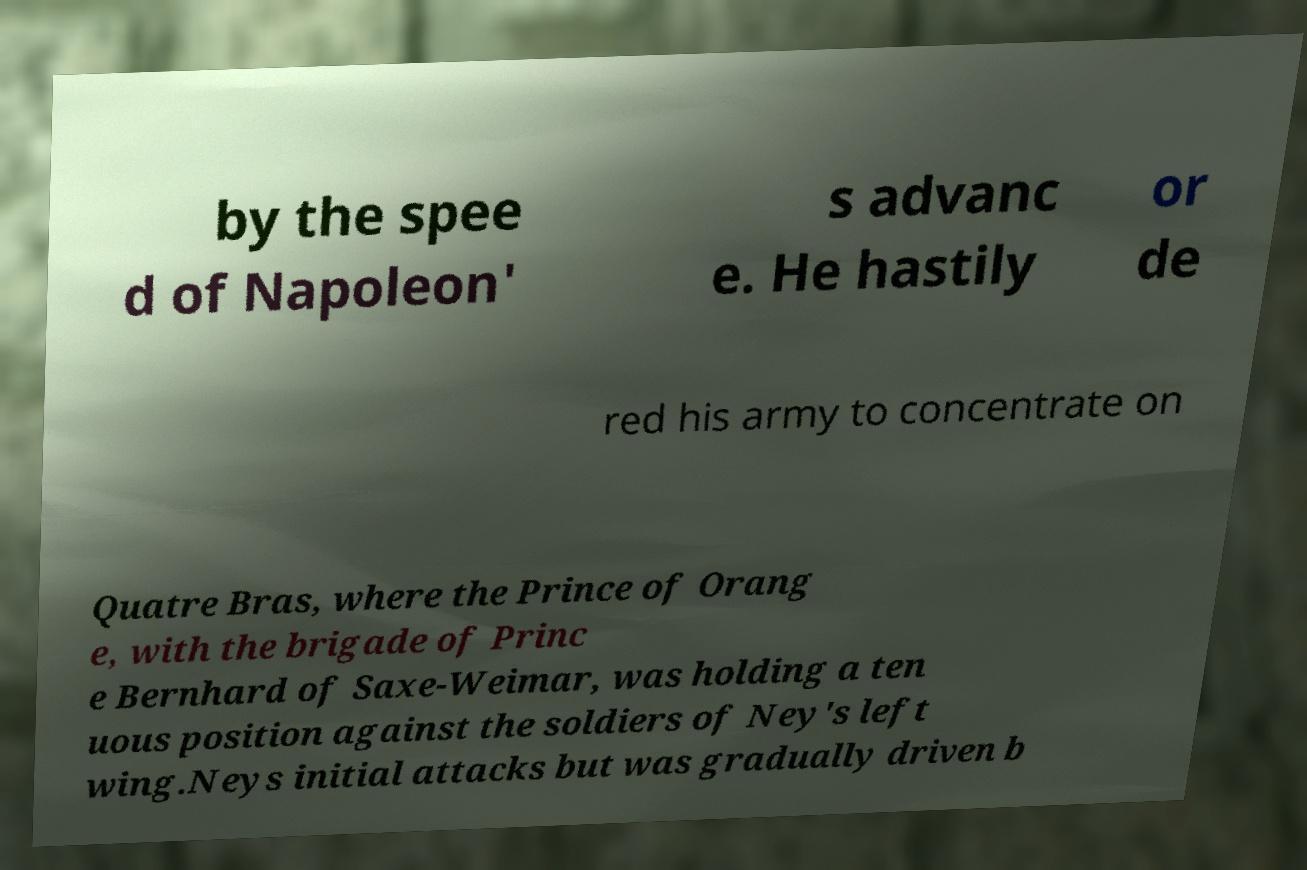What messages or text are displayed in this image? I need them in a readable, typed format. by the spee d of Napoleon' s advanc e. He hastily or de red his army to concentrate on Quatre Bras, where the Prince of Orang e, with the brigade of Princ e Bernhard of Saxe-Weimar, was holding a ten uous position against the soldiers of Ney's left wing.Neys initial attacks but was gradually driven b 